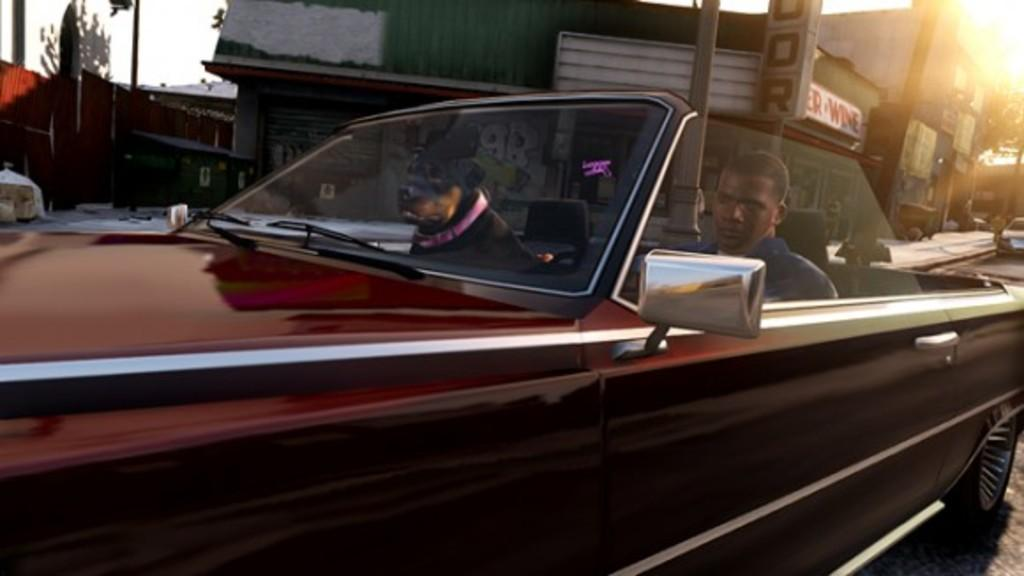Who or what is inside the car in the image? There is a person and a dog in the car. Where is the car located in the image? The car is on the road. What can be seen in the background of the image? There is a building and trees in the background of the image. What type of cracker is the person eating in the image? There is no cracker present in the image, and the person's actions are not described. How does the person wave to the trees in the background? There is no indication that the person is waving to the trees in the background, as their actions are not described. 